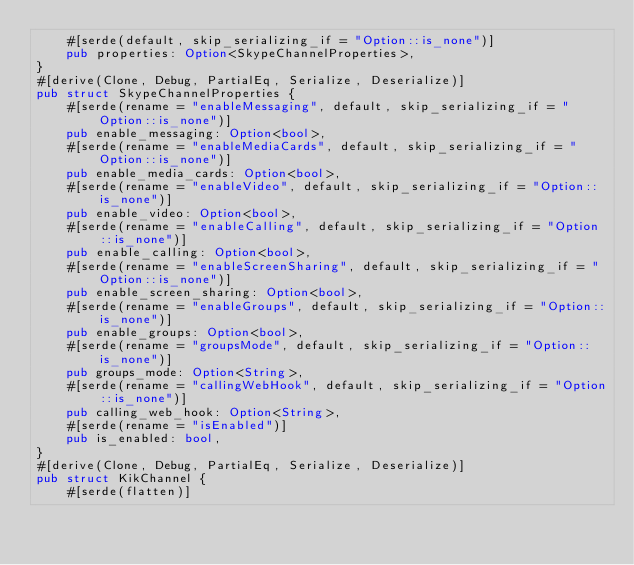<code> <loc_0><loc_0><loc_500><loc_500><_Rust_>    #[serde(default, skip_serializing_if = "Option::is_none")]
    pub properties: Option<SkypeChannelProperties>,
}
#[derive(Clone, Debug, PartialEq, Serialize, Deserialize)]
pub struct SkypeChannelProperties {
    #[serde(rename = "enableMessaging", default, skip_serializing_if = "Option::is_none")]
    pub enable_messaging: Option<bool>,
    #[serde(rename = "enableMediaCards", default, skip_serializing_if = "Option::is_none")]
    pub enable_media_cards: Option<bool>,
    #[serde(rename = "enableVideo", default, skip_serializing_if = "Option::is_none")]
    pub enable_video: Option<bool>,
    #[serde(rename = "enableCalling", default, skip_serializing_if = "Option::is_none")]
    pub enable_calling: Option<bool>,
    #[serde(rename = "enableScreenSharing", default, skip_serializing_if = "Option::is_none")]
    pub enable_screen_sharing: Option<bool>,
    #[serde(rename = "enableGroups", default, skip_serializing_if = "Option::is_none")]
    pub enable_groups: Option<bool>,
    #[serde(rename = "groupsMode", default, skip_serializing_if = "Option::is_none")]
    pub groups_mode: Option<String>,
    #[serde(rename = "callingWebHook", default, skip_serializing_if = "Option::is_none")]
    pub calling_web_hook: Option<String>,
    #[serde(rename = "isEnabled")]
    pub is_enabled: bool,
}
#[derive(Clone, Debug, PartialEq, Serialize, Deserialize)]
pub struct KikChannel {
    #[serde(flatten)]</code> 